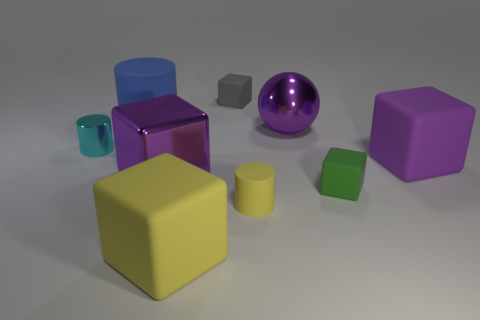What is the material of the other cube that is the same color as the shiny block?
Provide a succinct answer. Rubber. There is a big metallic object that is the same color as the metal cube; what is its shape?
Offer a very short reply. Sphere. There is a big purple object left of the metallic sphere; what number of big objects are in front of it?
Offer a very short reply. 1. Do the large cylinder and the green thing have the same material?
Provide a short and direct response. Yes. What number of matte blocks are in front of the metal sphere on the left side of the small rubber block that is in front of the purple metallic cube?
Your response must be concise. 3. There is a big rubber cube that is in front of the purple rubber thing; what is its color?
Offer a terse response. Yellow. What shape is the large purple object behind the small object to the left of the gray cube?
Offer a terse response. Sphere. Is the color of the metallic block the same as the ball?
Give a very brief answer. Yes. What number of spheres are either purple rubber objects or small shiny objects?
Offer a very short reply. 0. The thing that is both behind the big shiny ball and on the right side of the large cylinder is made of what material?
Provide a short and direct response. Rubber. 